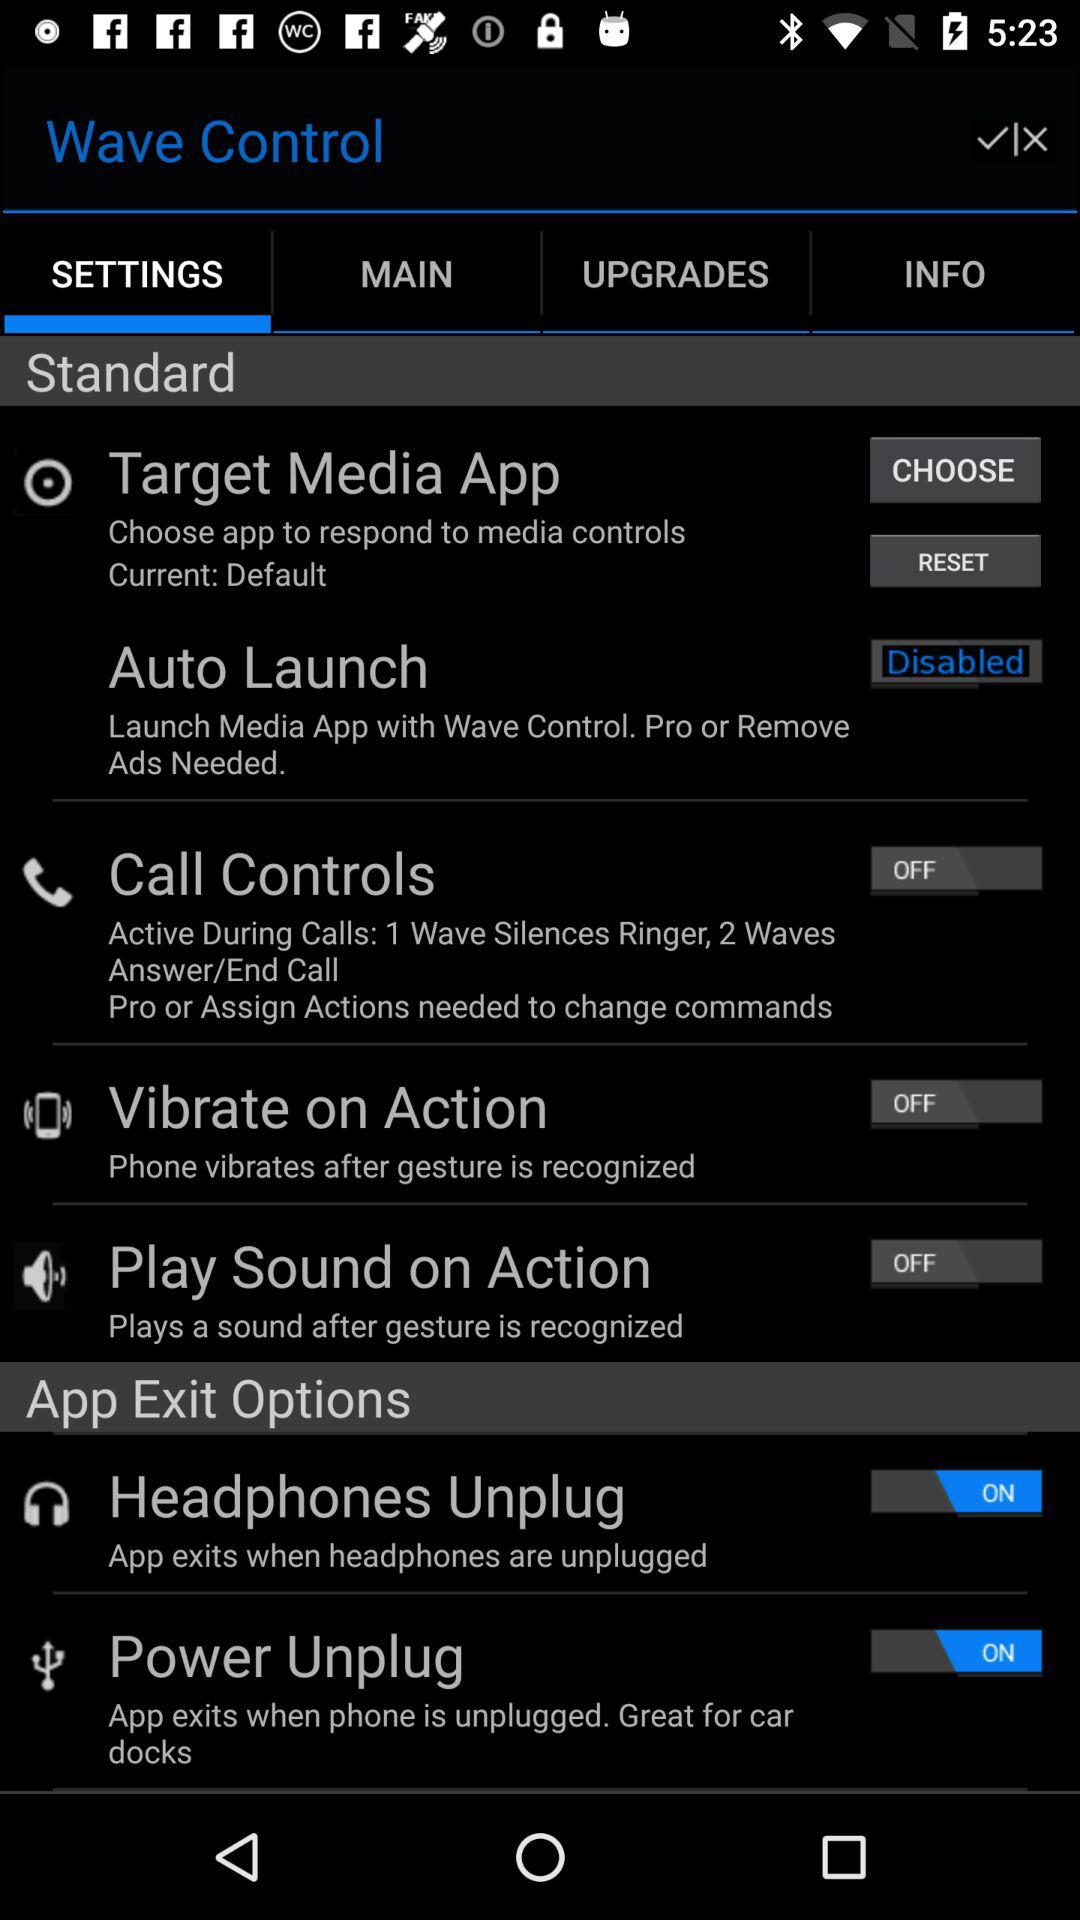Which tab was selected? The selected tab was "SETTINGS". 